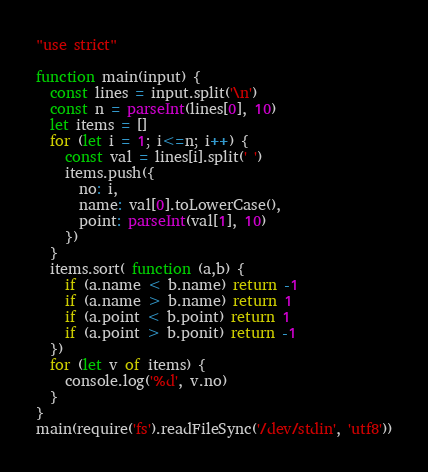<code> <loc_0><loc_0><loc_500><loc_500><_JavaScript_>"use strict"

function main(input) {
  const lines = input.split('\n')
  const n = parseInt(lines[0], 10)
  let items = []
  for (let i = 1; i<=n; i++) {
    const val = lines[i].split(' ')
    items.push({
      no: i,
      name: val[0].toLowerCase(),
      point: parseInt(val[1], 10)
    })
  }
  items.sort( function (a,b) {
    if (a.name < b.name) return -1
    if (a.name > b.name) return 1
    if (a.point < b.point) return 1
    if (a.point > b.ponit) return -1
  })
  for (let v of items) {
    console.log('%d', v.no)
  }
} 
main(require('fs').readFileSync('/dev/stdin', 'utf8'))</code> 